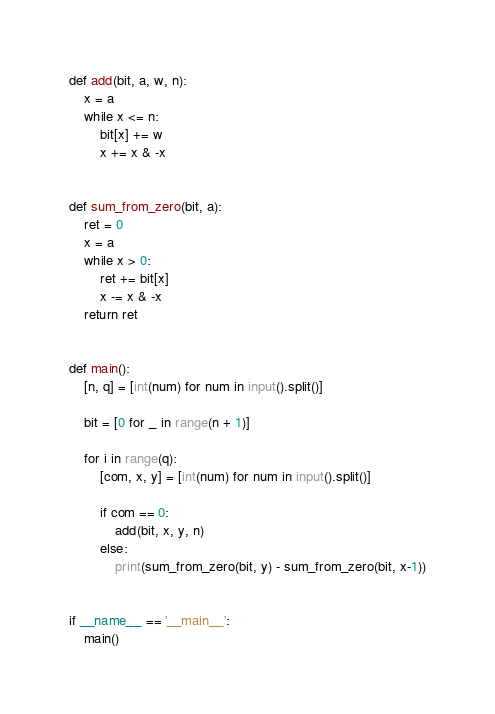<code> <loc_0><loc_0><loc_500><loc_500><_Python_>def add(bit, a, w, n):
    x = a
    while x <= n:
        bit[x] += w
        x += x & -x


def sum_from_zero(bit, a):
    ret = 0
    x = a
    while x > 0:
        ret += bit[x]
        x -= x & -x
    return ret


def main():
    [n, q] = [int(num) for num in input().split()]

    bit = [0 for _ in range(n + 1)]

    for i in range(q):
        [com, x, y] = [int(num) for num in input().split()]

        if com == 0:
            add(bit, x, y, n)
        else:
            print(sum_from_zero(bit, y) - sum_from_zero(bit, x-1))


if __name__ == '__main__':
    main()

</code> 